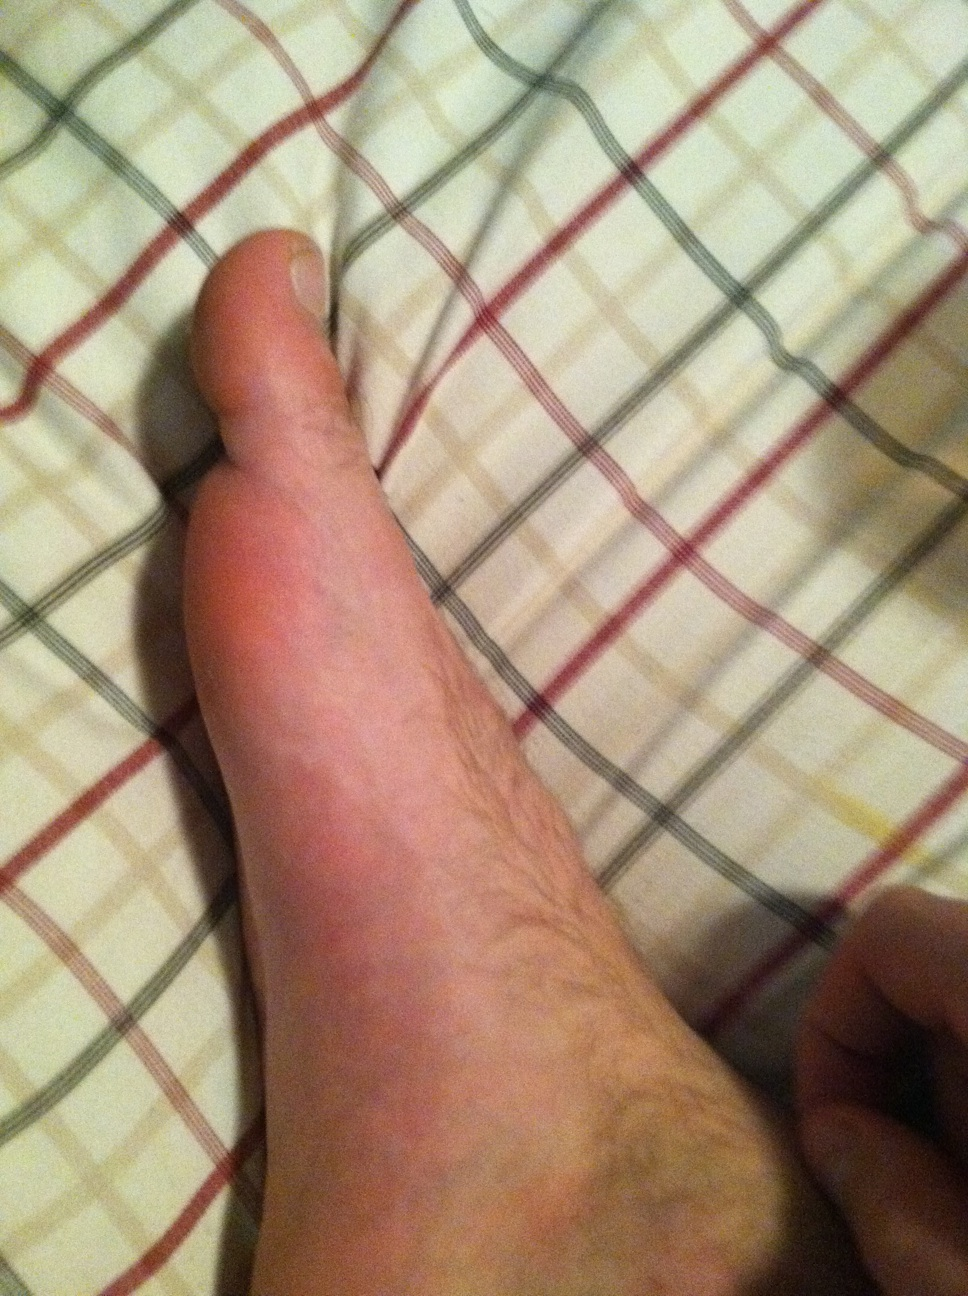Is there anything in this image that suggests the time of day or season? The image itself does not provide clear indicators of the time of day or season. The indoor setting and the style of the checkered surface, which might be bed linens, could suggest it is taken inside a home at any time. The lack of natural light or outdoor elements also means we cannot deduce the season or the time of day from the photo alone. 